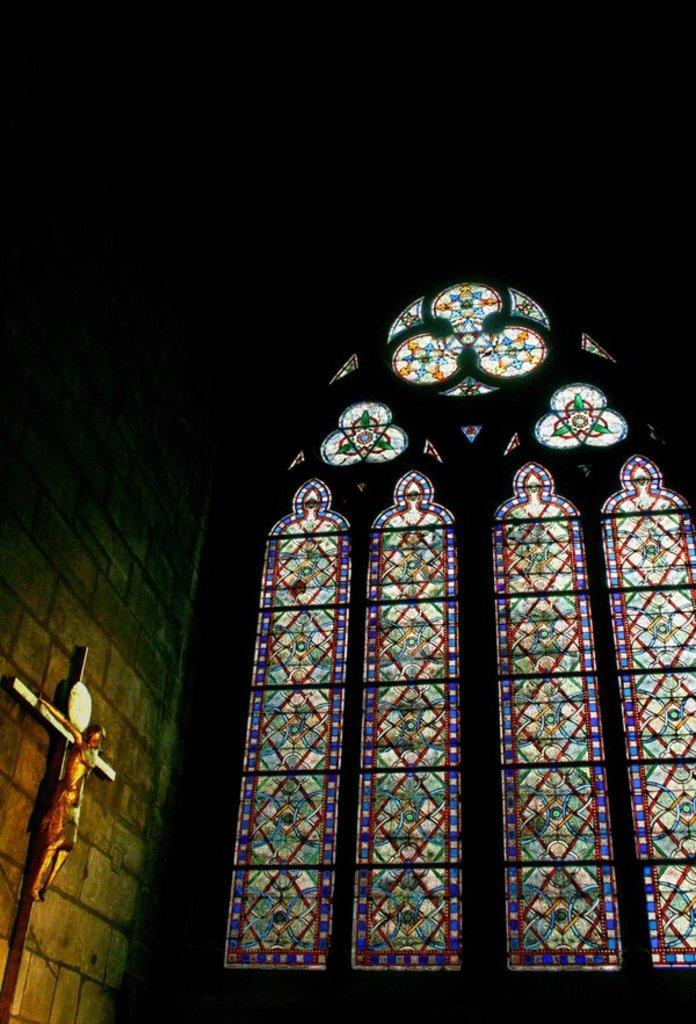What type of building is depicted in the image? There is a church in the image. What is present on the wall of the church? The wall has glass and a cross symbol, as well as a statue. Can you describe the cross symbol on the wall? The cross symbol on the wall is a religious symbol commonly associated with Christianity. What statement does the minister make in the image? There is no minister present in the image, so it is not possible to determine what statement they might make. 